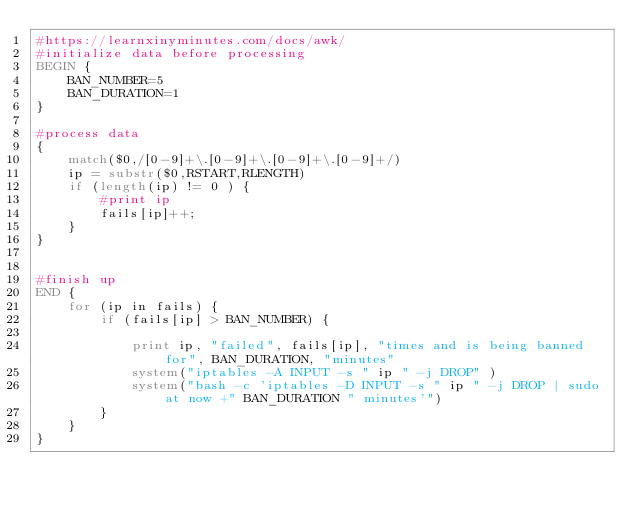Convert code to text. <code><loc_0><loc_0><loc_500><loc_500><_Awk_>#https://learnxinyminutes.com/docs/awk/
#initialize data before processing
BEGIN {
    BAN_NUMBER=5
    BAN_DURATION=1
}  

#process data
{
    match($0,/[0-9]+\.[0-9]+\.[0-9]+\.[0-9]+/)
    ip = substr($0,RSTART,RLENGTH)
    if (length(ip) != 0 ) {
        #print ip
        fails[ip]++;
    }
}


#finish up
END {
    for (ip in fails) {
        if (fails[ip] > BAN_NUMBER) {

            print ip, "failed", fails[ip], "times and is being banned for", BAN_DURATION, "minutes"
            system("iptables -A INPUT -s " ip " -j DROP" )
            system("bash -c 'iptables -D INPUT -s " ip " -j DROP | sudo at now +" BAN_DURATION " minutes'")
        }
    }
}</code> 